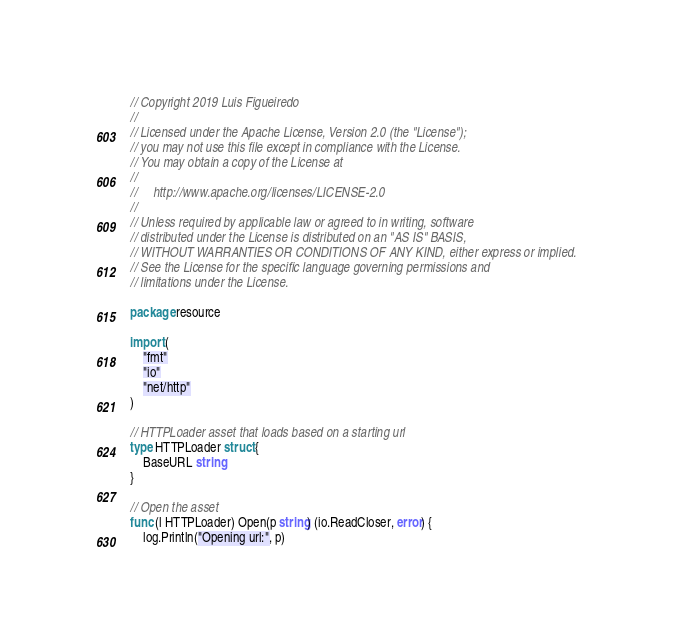<code> <loc_0><loc_0><loc_500><loc_500><_Go_>// Copyright 2019 Luis Figueiredo
//
// Licensed under the Apache License, Version 2.0 (the "License");
// you may not use this file except in compliance with the License.
// You may obtain a copy of the License at
//
//     http://www.apache.org/licenses/LICENSE-2.0
//
// Unless required by applicable law or agreed to in writing, software
// distributed under the License is distributed on an "AS IS" BASIS,
// WITHOUT WARRANTIES OR CONDITIONS OF ANY KIND, either express or implied.
// See the License for the specific language governing permissions and
// limitations under the License.

package resource

import (
	"fmt"
	"io"
	"net/http"
)

// HTTPLoader asset that loads based on a starting url
type HTTPLoader struct {
	BaseURL string
}

// Open the asset
func (l HTTPLoader) Open(p string) (io.ReadCloser, error) {
	log.Println("Opening url:", p)</code> 